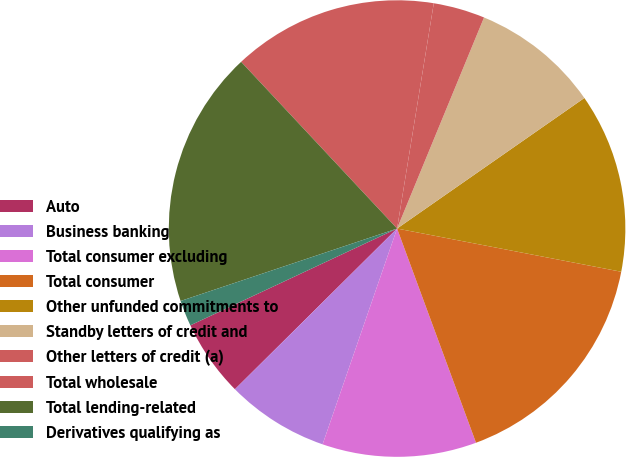Convert chart to OTSL. <chart><loc_0><loc_0><loc_500><loc_500><pie_chart><fcel>Auto<fcel>Business banking<fcel>Total consumer excluding<fcel>Total consumer<fcel>Other unfunded commitments to<fcel>Standby letters of credit and<fcel>Other letters of credit (a)<fcel>Total wholesale<fcel>Total lending-related<fcel>Derivatives qualifying as<nl><fcel>5.46%<fcel>7.28%<fcel>10.91%<fcel>16.35%<fcel>12.72%<fcel>9.09%<fcel>3.65%<fcel>14.54%<fcel>18.17%<fcel>1.83%<nl></chart> 